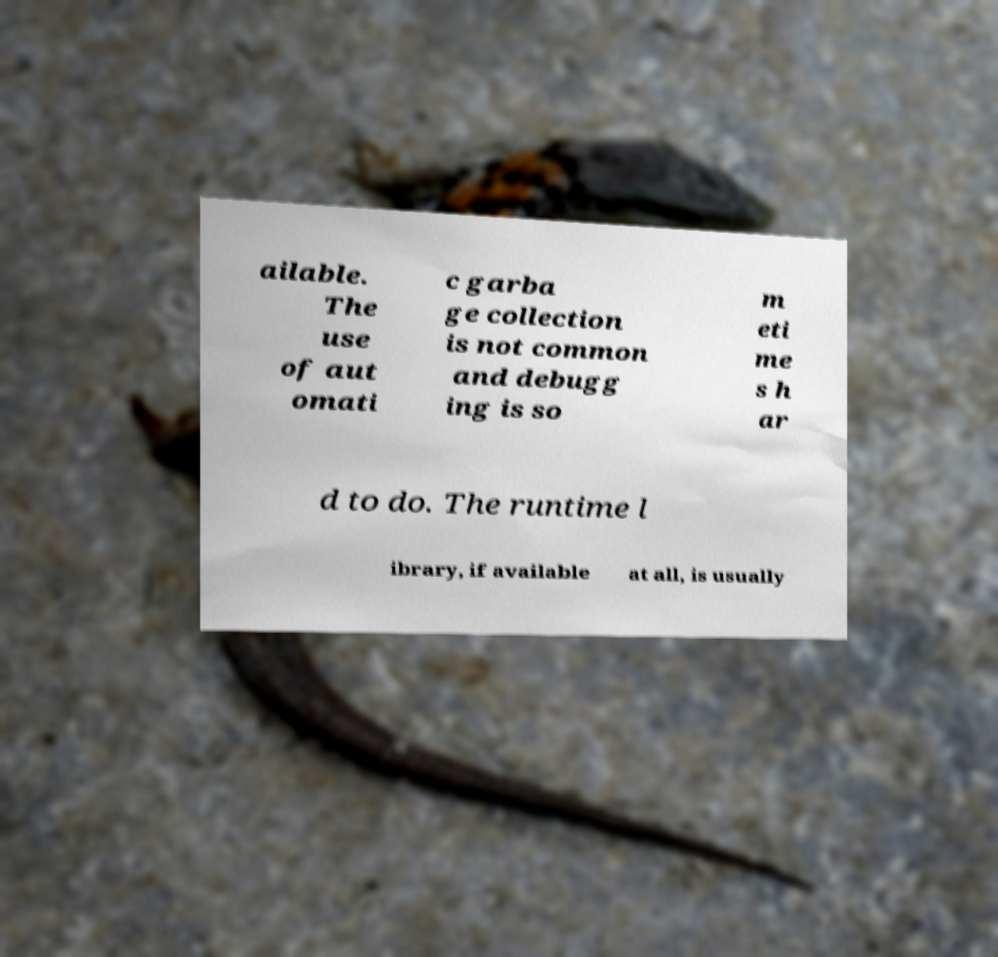There's text embedded in this image that I need extracted. Can you transcribe it verbatim? ailable. The use of aut omati c garba ge collection is not common and debugg ing is so m eti me s h ar d to do. The runtime l ibrary, if available at all, is usually 